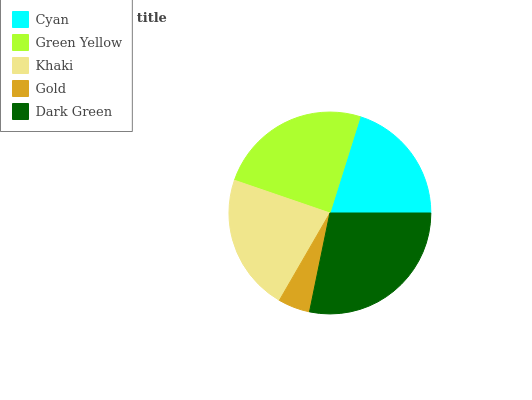Is Gold the minimum?
Answer yes or no. Yes. Is Dark Green the maximum?
Answer yes or no. Yes. Is Green Yellow the minimum?
Answer yes or no. No. Is Green Yellow the maximum?
Answer yes or no. No. Is Green Yellow greater than Cyan?
Answer yes or no. Yes. Is Cyan less than Green Yellow?
Answer yes or no. Yes. Is Cyan greater than Green Yellow?
Answer yes or no. No. Is Green Yellow less than Cyan?
Answer yes or no. No. Is Khaki the high median?
Answer yes or no. Yes. Is Khaki the low median?
Answer yes or no. Yes. Is Green Yellow the high median?
Answer yes or no. No. Is Green Yellow the low median?
Answer yes or no. No. 